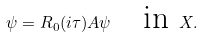Convert formula to latex. <formula><loc_0><loc_0><loc_500><loc_500>\psi = R _ { 0 } ( i \tau ) A \psi \quad \text {in } X .</formula> 